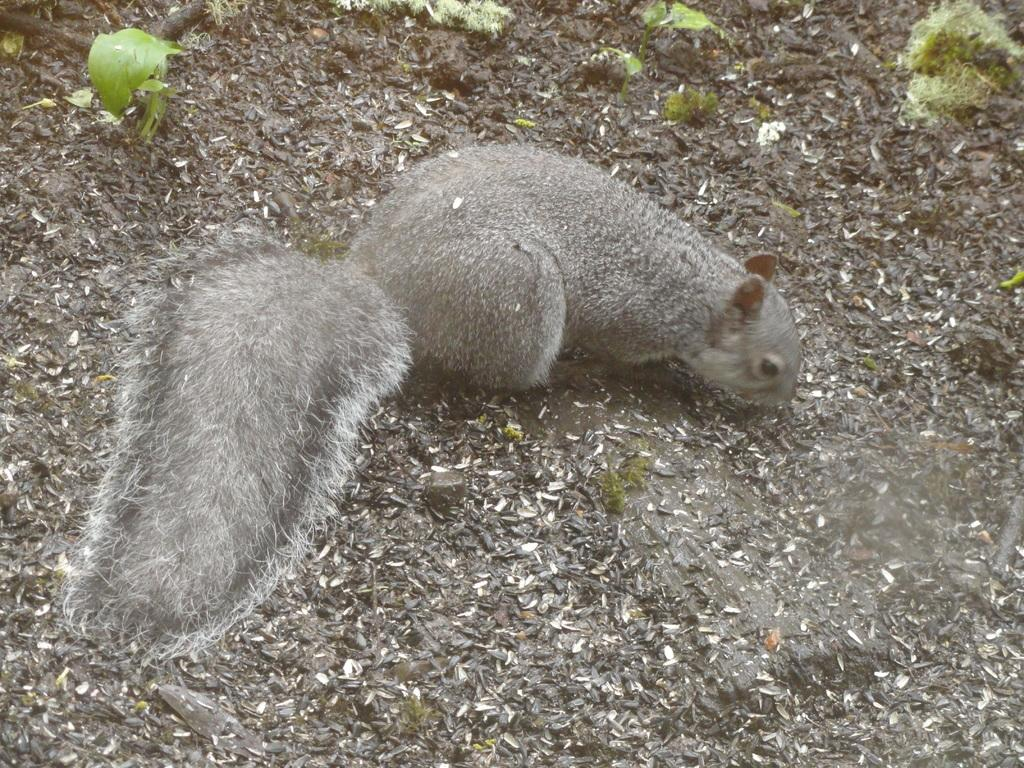What type of animal is in the image? There is a squirrel in the image. What is located behind the squirrel in the image? There are tiny plants behind the squirrel in the image. What type of guitar is the squirrel playing in the image? There is no guitar present in the image; it features a squirrel and tiny plants. 